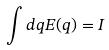<formula> <loc_0><loc_0><loc_500><loc_500>\int d q E ( q ) = I</formula> 